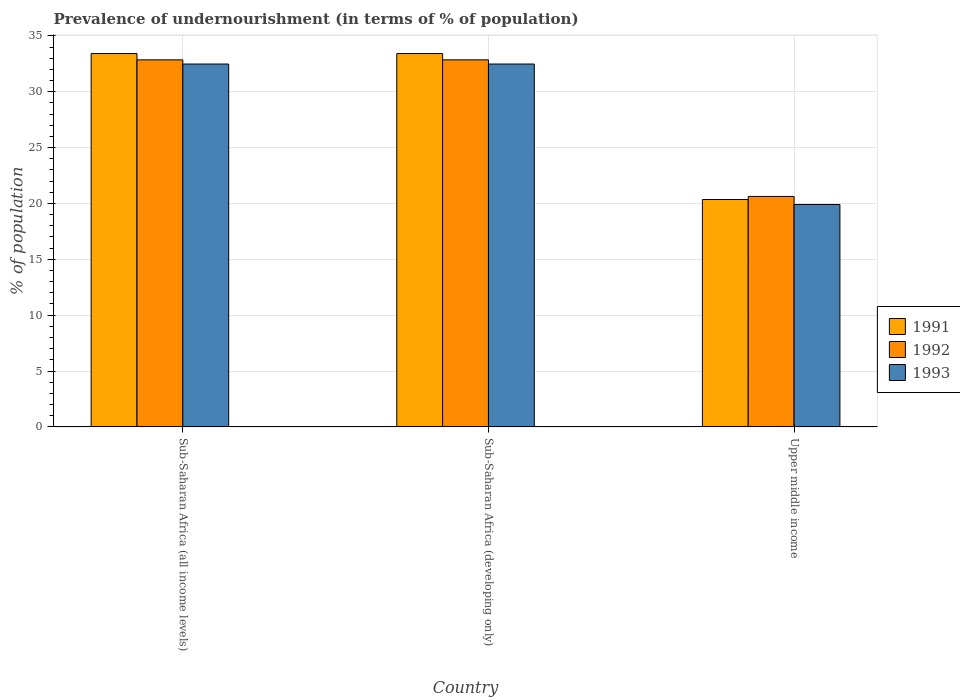How many different coloured bars are there?
Keep it short and to the point. 3. How many groups of bars are there?
Provide a succinct answer. 3. Are the number of bars per tick equal to the number of legend labels?
Provide a succinct answer. Yes. How many bars are there on the 2nd tick from the right?
Your answer should be compact. 3. What is the label of the 2nd group of bars from the left?
Make the answer very short. Sub-Saharan Africa (developing only). What is the percentage of undernourished population in 1992 in Upper middle income?
Your response must be concise. 20.63. Across all countries, what is the maximum percentage of undernourished population in 1993?
Provide a short and direct response. 32.48. Across all countries, what is the minimum percentage of undernourished population in 1993?
Your answer should be compact. 19.91. In which country was the percentage of undernourished population in 1992 maximum?
Keep it short and to the point. Sub-Saharan Africa (all income levels). In which country was the percentage of undernourished population in 1993 minimum?
Provide a succinct answer. Upper middle income. What is the total percentage of undernourished population in 1993 in the graph?
Provide a short and direct response. 84.87. What is the difference between the percentage of undernourished population in 1991 in Sub-Saharan Africa (all income levels) and that in Upper middle income?
Offer a terse response. 13.07. What is the difference between the percentage of undernourished population in 1992 in Upper middle income and the percentage of undernourished population in 1991 in Sub-Saharan Africa (all income levels)?
Offer a terse response. -12.79. What is the average percentage of undernourished population in 1993 per country?
Keep it short and to the point. 28.29. What is the difference between the percentage of undernourished population of/in 1991 and percentage of undernourished population of/in 1993 in Sub-Saharan Africa (all income levels)?
Provide a short and direct response. 0.94. In how many countries, is the percentage of undernourished population in 1992 greater than 27 %?
Ensure brevity in your answer.  2. What is the ratio of the percentage of undernourished population in 1993 in Sub-Saharan Africa (developing only) to that in Upper middle income?
Provide a short and direct response. 1.63. What is the difference between the highest and the second highest percentage of undernourished population in 1993?
Your response must be concise. 12.58. What is the difference between the highest and the lowest percentage of undernourished population in 1991?
Offer a very short reply. 13.07. In how many countries, is the percentage of undernourished population in 1993 greater than the average percentage of undernourished population in 1993 taken over all countries?
Offer a very short reply. 2. Is the sum of the percentage of undernourished population in 1992 in Sub-Saharan Africa (all income levels) and Upper middle income greater than the maximum percentage of undernourished population in 1991 across all countries?
Give a very brief answer. Yes. What does the 1st bar from the right in Sub-Saharan Africa (all income levels) represents?
Offer a terse response. 1993. Is it the case that in every country, the sum of the percentage of undernourished population in 1991 and percentage of undernourished population in 1993 is greater than the percentage of undernourished population in 1992?
Your answer should be compact. Yes. Are all the bars in the graph horizontal?
Provide a short and direct response. No. What is the difference between two consecutive major ticks on the Y-axis?
Your answer should be compact. 5. Does the graph contain grids?
Keep it short and to the point. Yes. Where does the legend appear in the graph?
Keep it short and to the point. Center right. What is the title of the graph?
Provide a succinct answer. Prevalence of undernourishment (in terms of % of population). Does "1977" appear as one of the legend labels in the graph?
Make the answer very short. No. What is the label or title of the X-axis?
Make the answer very short. Country. What is the label or title of the Y-axis?
Provide a succinct answer. % of population. What is the % of population of 1991 in Sub-Saharan Africa (all income levels)?
Your response must be concise. 33.42. What is the % of population of 1992 in Sub-Saharan Africa (all income levels)?
Provide a succinct answer. 32.86. What is the % of population of 1993 in Sub-Saharan Africa (all income levels)?
Offer a very short reply. 32.48. What is the % of population of 1991 in Sub-Saharan Africa (developing only)?
Make the answer very short. 33.42. What is the % of population of 1992 in Sub-Saharan Africa (developing only)?
Give a very brief answer. 32.86. What is the % of population of 1993 in Sub-Saharan Africa (developing only)?
Your answer should be very brief. 32.48. What is the % of population in 1991 in Upper middle income?
Your answer should be very brief. 20.35. What is the % of population in 1992 in Upper middle income?
Give a very brief answer. 20.63. What is the % of population of 1993 in Upper middle income?
Your answer should be very brief. 19.91. Across all countries, what is the maximum % of population in 1991?
Offer a terse response. 33.42. Across all countries, what is the maximum % of population in 1992?
Give a very brief answer. 32.86. Across all countries, what is the maximum % of population in 1993?
Keep it short and to the point. 32.48. Across all countries, what is the minimum % of population of 1991?
Offer a terse response. 20.35. Across all countries, what is the minimum % of population of 1992?
Give a very brief answer. 20.63. Across all countries, what is the minimum % of population in 1993?
Give a very brief answer. 19.91. What is the total % of population of 1991 in the graph?
Make the answer very short. 87.2. What is the total % of population of 1992 in the graph?
Your response must be concise. 86.34. What is the total % of population of 1993 in the graph?
Your response must be concise. 84.87. What is the difference between the % of population in 1993 in Sub-Saharan Africa (all income levels) and that in Sub-Saharan Africa (developing only)?
Provide a short and direct response. 0. What is the difference between the % of population in 1991 in Sub-Saharan Africa (all income levels) and that in Upper middle income?
Offer a very short reply. 13.07. What is the difference between the % of population in 1992 in Sub-Saharan Africa (all income levels) and that in Upper middle income?
Ensure brevity in your answer.  12.23. What is the difference between the % of population in 1993 in Sub-Saharan Africa (all income levels) and that in Upper middle income?
Provide a succinct answer. 12.58. What is the difference between the % of population of 1991 in Sub-Saharan Africa (developing only) and that in Upper middle income?
Provide a short and direct response. 13.07. What is the difference between the % of population of 1992 in Sub-Saharan Africa (developing only) and that in Upper middle income?
Offer a very short reply. 12.23. What is the difference between the % of population in 1993 in Sub-Saharan Africa (developing only) and that in Upper middle income?
Offer a very short reply. 12.58. What is the difference between the % of population in 1991 in Sub-Saharan Africa (all income levels) and the % of population in 1992 in Sub-Saharan Africa (developing only)?
Your response must be concise. 0.57. What is the difference between the % of population in 1991 in Sub-Saharan Africa (all income levels) and the % of population in 1993 in Sub-Saharan Africa (developing only)?
Provide a short and direct response. 0.94. What is the difference between the % of population of 1992 in Sub-Saharan Africa (all income levels) and the % of population of 1993 in Sub-Saharan Africa (developing only)?
Your answer should be compact. 0.37. What is the difference between the % of population in 1991 in Sub-Saharan Africa (all income levels) and the % of population in 1992 in Upper middle income?
Ensure brevity in your answer.  12.79. What is the difference between the % of population of 1991 in Sub-Saharan Africa (all income levels) and the % of population of 1993 in Upper middle income?
Keep it short and to the point. 13.51. What is the difference between the % of population in 1992 in Sub-Saharan Africa (all income levels) and the % of population in 1993 in Upper middle income?
Your response must be concise. 12.95. What is the difference between the % of population in 1991 in Sub-Saharan Africa (developing only) and the % of population in 1992 in Upper middle income?
Your answer should be compact. 12.79. What is the difference between the % of population of 1991 in Sub-Saharan Africa (developing only) and the % of population of 1993 in Upper middle income?
Keep it short and to the point. 13.51. What is the difference between the % of population of 1992 in Sub-Saharan Africa (developing only) and the % of population of 1993 in Upper middle income?
Ensure brevity in your answer.  12.95. What is the average % of population in 1991 per country?
Make the answer very short. 29.07. What is the average % of population of 1992 per country?
Offer a terse response. 28.78. What is the average % of population in 1993 per country?
Offer a terse response. 28.29. What is the difference between the % of population in 1991 and % of population in 1992 in Sub-Saharan Africa (all income levels)?
Your answer should be very brief. 0.57. What is the difference between the % of population of 1991 and % of population of 1993 in Sub-Saharan Africa (all income levels)?
Your answer should be very brief. 0.94. What is the difference between the % of population of 1992 and % of population of 1993 in Sub-Saharan Africa (all income levels)?
Your answer should be very brief. 0.37. What is the difference between the % of population in 1991 and % of population in 1992 in Sub-Saharan Africa (developing only)?
Ensure brevity in your answer.  0.57. What is the difference between the % of population of 1991 and % of population of 1993 in Sub-Saharan Africa (developing only)?
Your response must be concise. 0.94. What is the difference between the % of population in 1992 and % of population in 1993 in Sub-Saharan Africa (developing only)?
Your response must be concise. 0.37. What is the difference between the % of population in 1991 and % of population in 1992 in Upper middle income?
Ensure brevity in your answer.  -0.28. What is the difference between the % of population of 1991 and % of population of 1993 in Upper middle income?
Give a very brief answer. 0.45. What is the difference between the % of population in 1992 and % of population in 1993 in Upper middle income?
Give a very brief answer. 0.72. What is the ratio of the % of population of 1991 in Sub-Saharan Africa (all income levels) to that in Sub-Saharan Africa (developing only)?
Provide a succinct answer. 1. What is the ratio of the % of population in 1991 in Sub-Saharan Africa (all income levels) to that in Upper middle income?
Keep it short and to the point. 1.64. What is the ratio of the % of population of 1992 in Sub-Saharan Africa (all income levels) to that in Upper middle income?
Provide a succinct answer. 1.59. What is the ratio of the % of population of 1993 in Sub-Saharan Africa (all income levels) to that in Upper middle income?
Provide a short and direct response. 1.63. What is the ratio of the % of population in 1991 in Sub-Saharan Africa (developing only) to that in Upper middle income?
Offer a terse response. 1.64. What is the ratio of the % of population in 1992 in Sub-Saharan Africa (developing only) to that in Upper middle income?
Your answer should be very brief. 1.59. What is the ratio of the % of population in 1993 in Sub-Saharan Africa (developing only) to that in Upper middle income?
Make the answer very short. 1.63. What is the difference between the highest and the lowest % of population of 1991?
Your answer should be very brief. 13.07. What is the difference between the highest and the lowest % of population in 1992?
Make the answer very short. 12.23. What is the difference between the highest and the lowest % of population in 1993?
Keep it short and to the point. 12.58. 